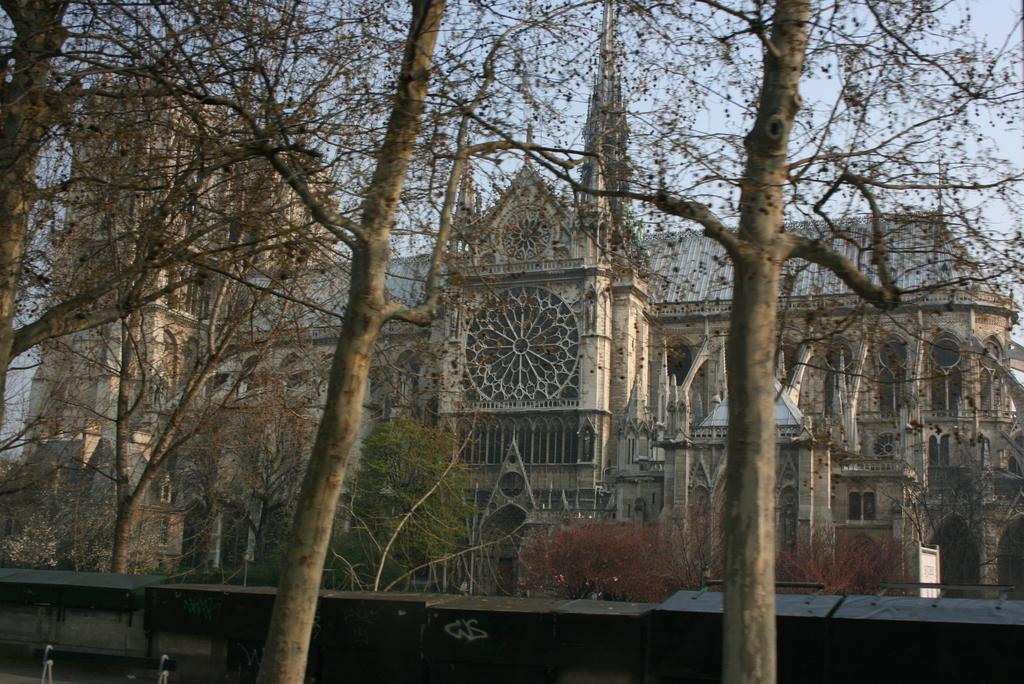What type of living organisms can be seen in the image? Plants and trees are visible in the image. What type of structure is present in the image? There is a building in the image. What part of the natural environment is visible in the image? The sky is visible in the image. Can you see any fog in the image? There is no fog visible in the image. What type of tooth can be seen in the image? There are no teeth present in the image. 